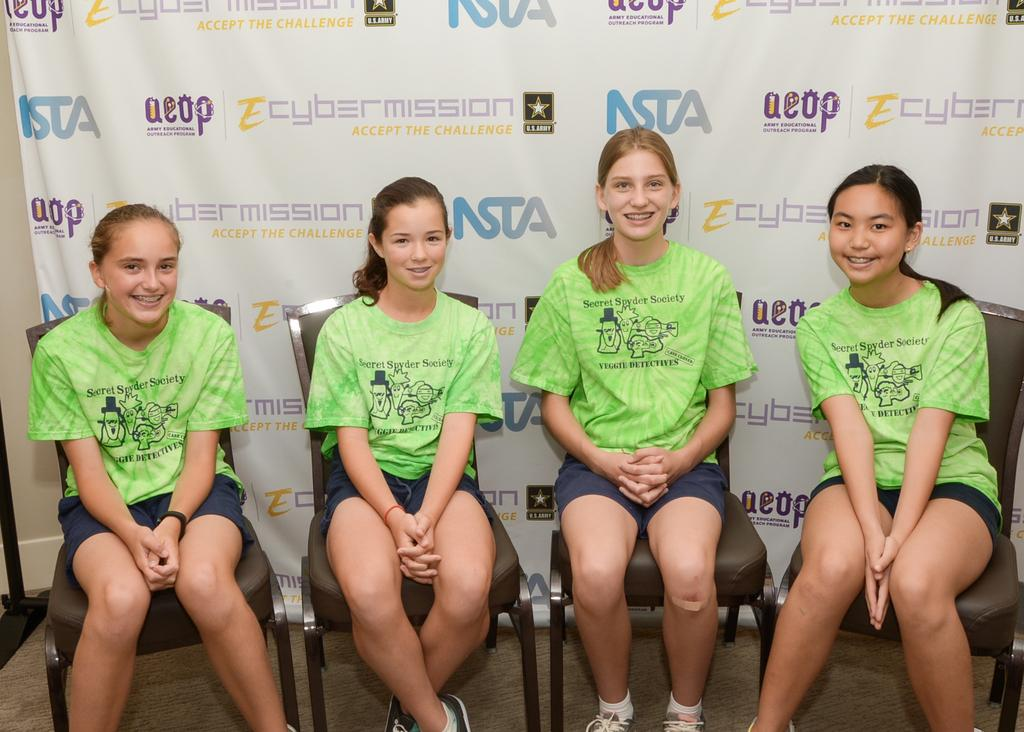How many girls are in the image? There are four girls in the image. What are the girls wearing? The girls are wearing green t-shirts and shorts. What are the girls doing in the image? The girls are sitting on chairs, smiling, and posing for the camera. What color is the banner visible in the background? The banner visible in the background is white. What type of crown is the girl wearing in the image? There is no crown present in the image; the girls are wearing green t-shirts and shorts. How many cents are visible on the banner in the image? There are no cents or any monetary value mentioned on the banner in the image; it is white in color. 